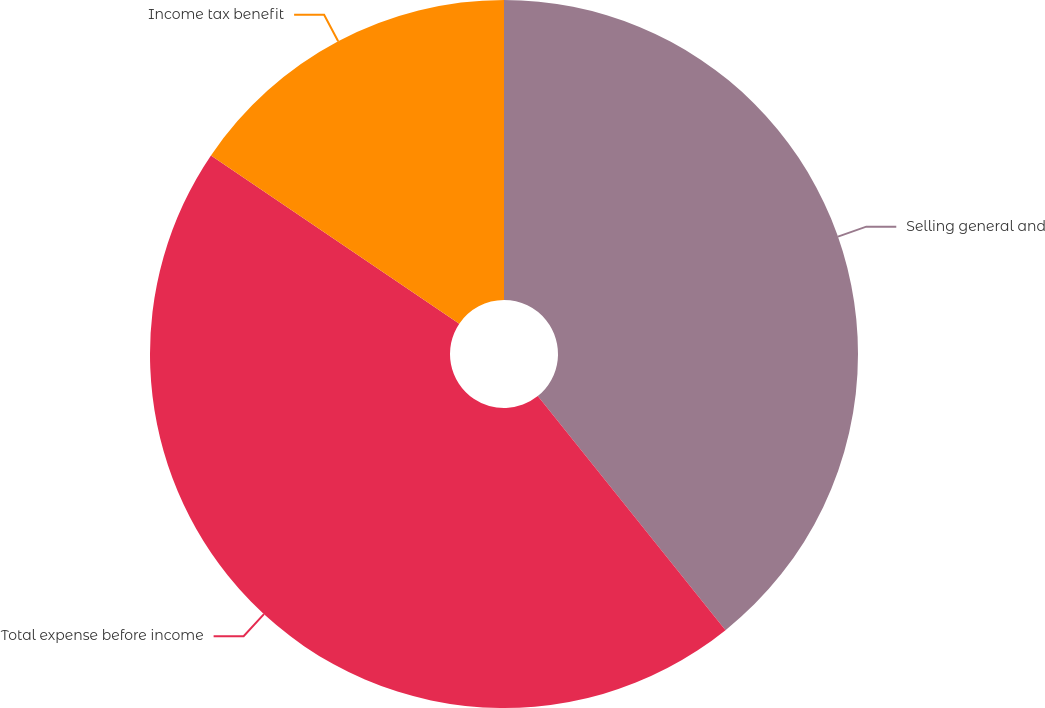Convert chart to OTSL. <chart><loc_0><loc_0><loc_500><loc_500><pie_chart><fcel>Selling general and<fcel>Total expense before income<fcel>Income tax benefit<nl><fcel>39.24%<fcel>45.24%<fcel>15.52%<nl></chart> 